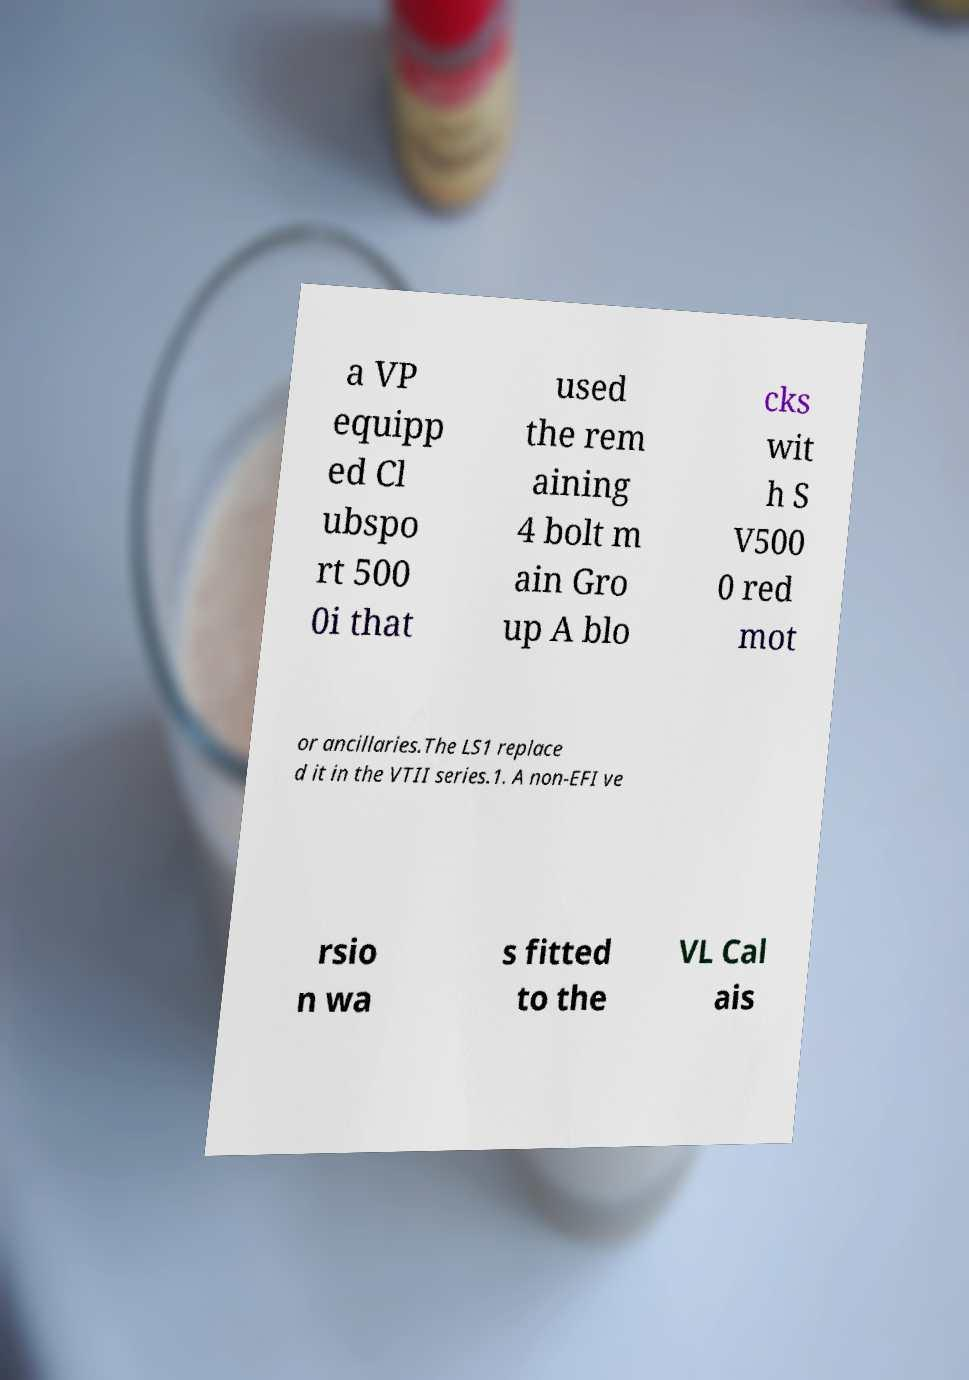Please read and relay the text visible in this image. What does it say? a VP equipp ed Cl ubspo rt 500 0i that used the rem aining 4 bolt m ain Gro up A blo cks wit h S V500 0 red mot or ancillaries.The LS1 replace d it in the VTII series.1. A non-EFI ve rsio n wa s fitted to the VL Cal ais 